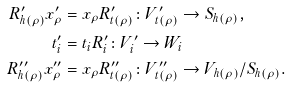Convert formula to latex. <formula><loc_0><loc_0><loc_500><loc_500>R ^ { \prime } _ { h ( \rho ) } x ^ { \prime } _ { \rho } & = x _ { \rho } R ^ { \prime } _ { t ( \rho ) } \colon V ^ { \prime } _ { t ( \rho ) } \to S _ { h ( \rho ) } , \\ t ^ { \prime } _ { i } & = t _ { i } R ^ { \prime } _ { i } \colon V ^ { \prime } _ { i } \to W _ { i } \\ R ^ { \prime \prime } _ { h ( \rho ) } x ^ { \prime \prime } _ { \rho } & = x _ { \rho } R ^ { \prime \prime } _ { t ( \rho ) } \colon V ^ { \prime \prime } _ { t ( \rho ) } \to V _ { h ( \rho ) } / S _ { h ( \rho ) } .</formula> 